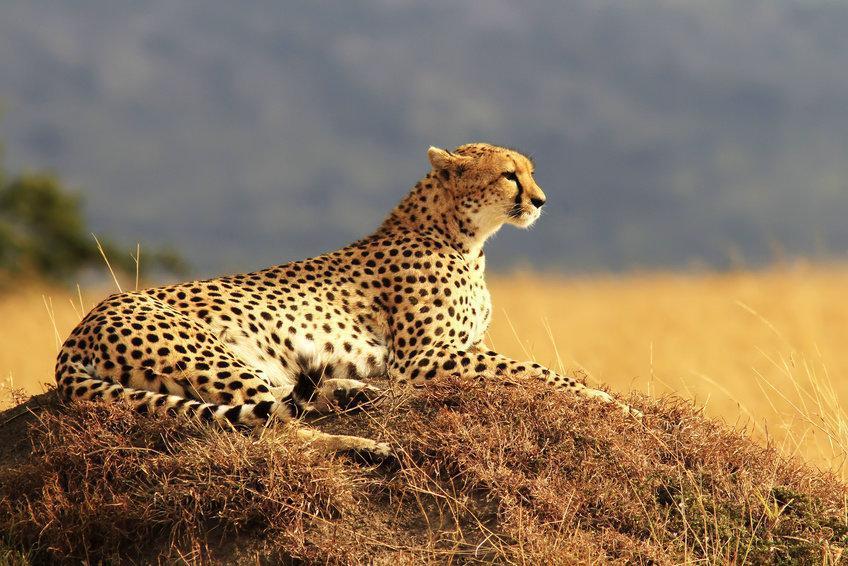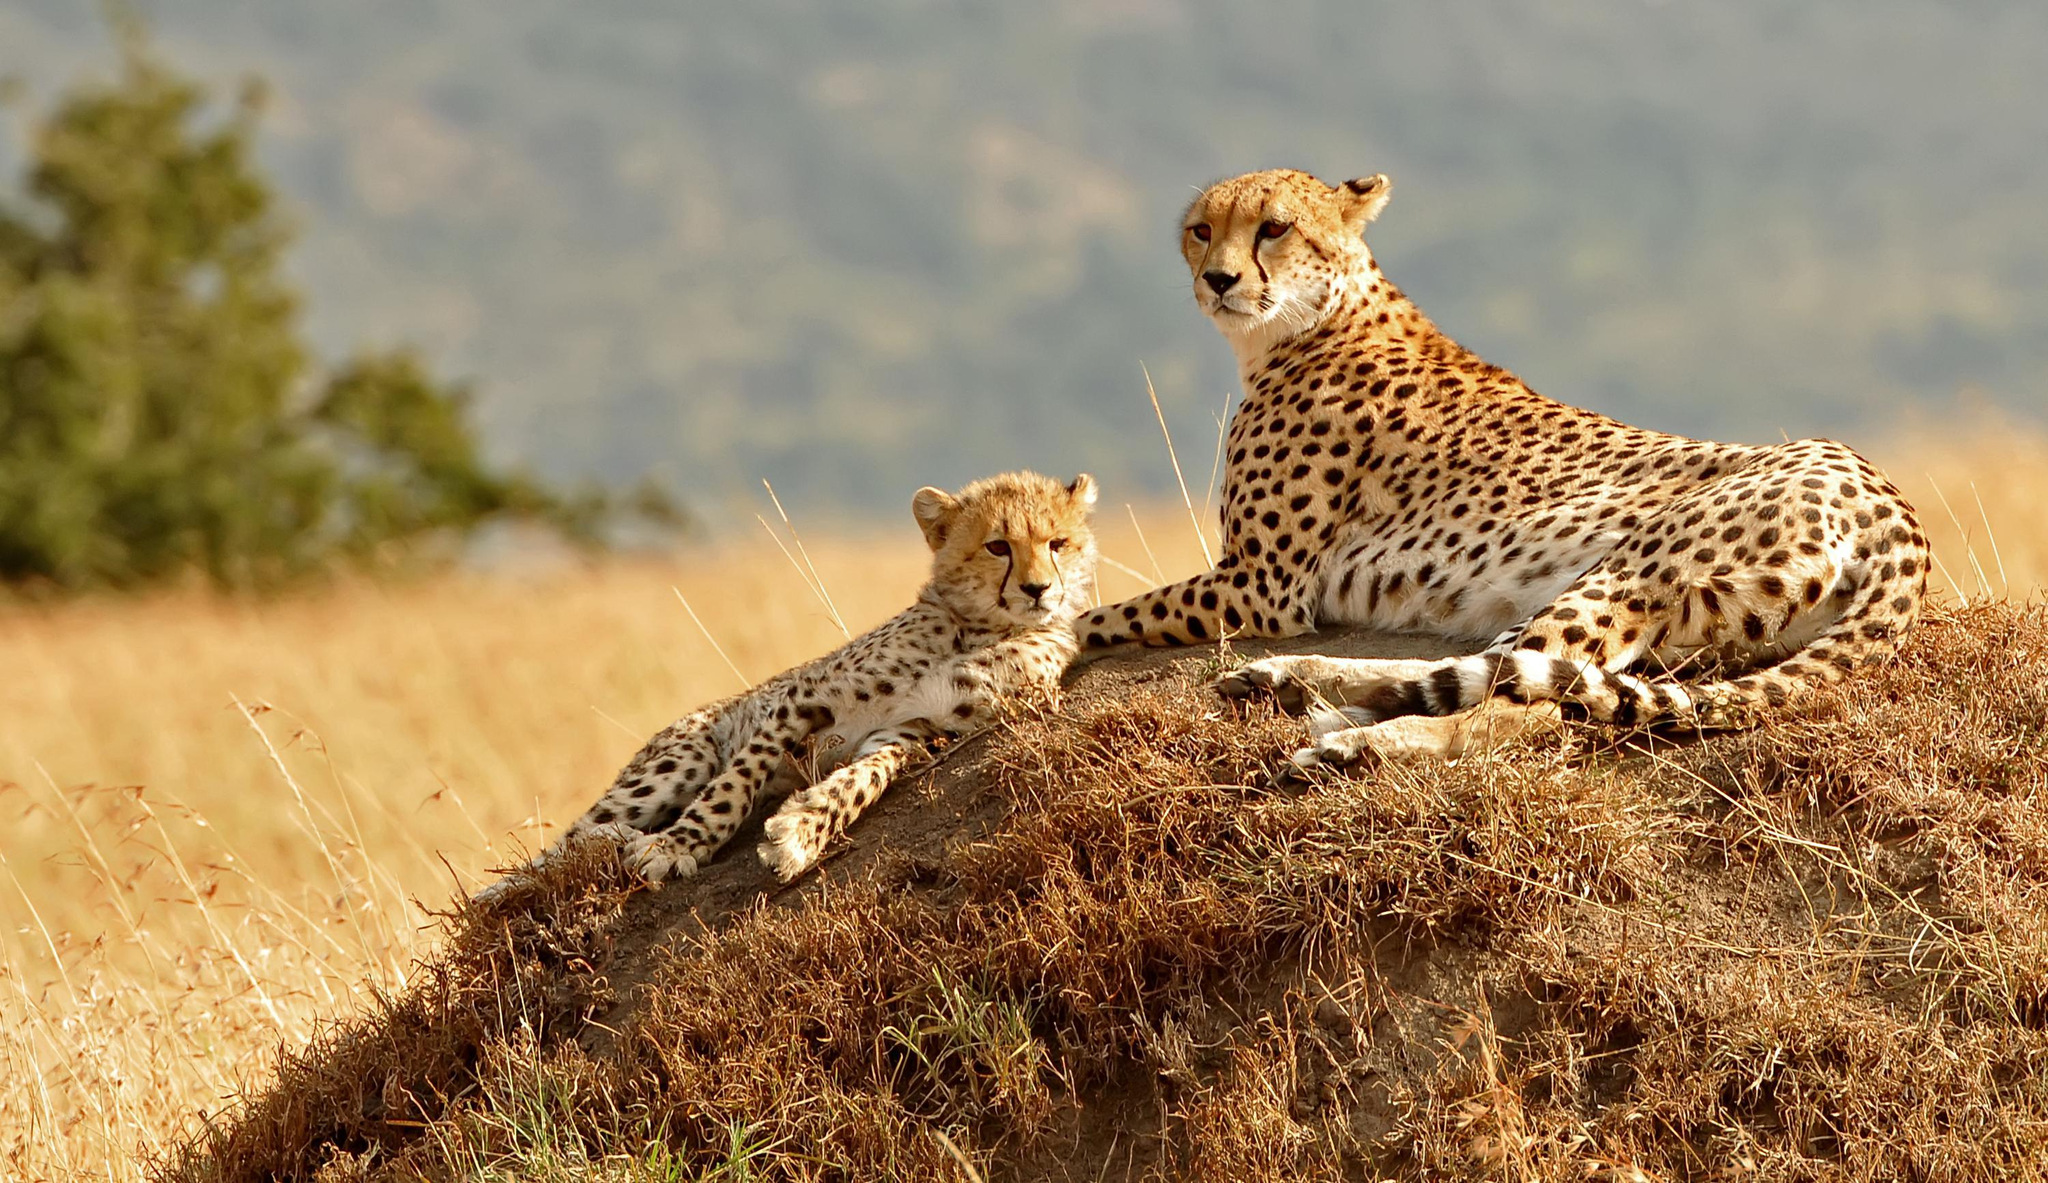The first image is the image on the left, the second image is the image on the right. Analyze the images presented: Is the assertion "In one of the images there are two cheetahs laying next to each other." valid? Answer yes or no. Yes. The first image is the image on the left, the second image is the image on the right. Evaluate the accuracy of this statement regarding the images: "One image shows a reclining adult spotted wild cat posed with a cub.". Is it true? Answer yes or no. Yes. 